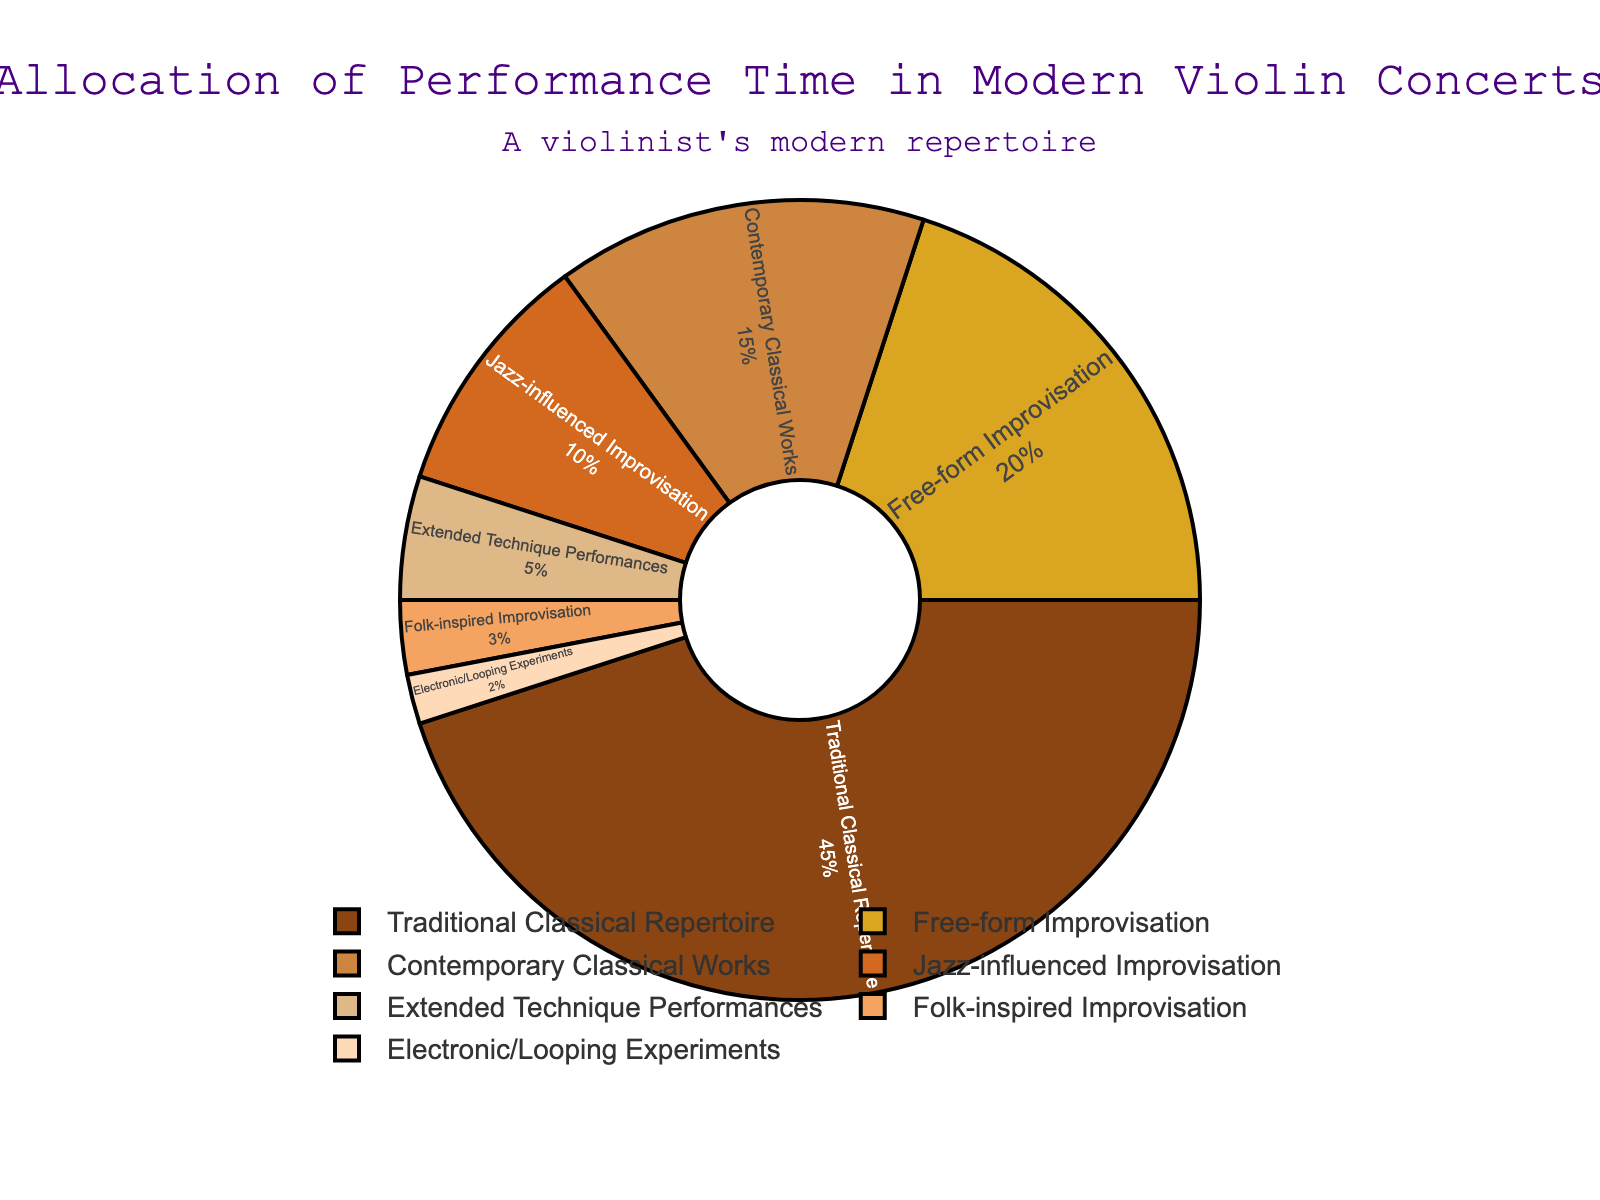What percentage of the performance time is allocated to improvisation (free-form, jazz-influenced, and folk-inspired combined)? Add percentages for Free-form Improvisation (20%), Jazz-influenced Improvisation (10%), and Folk-inspired Improvisation (3%): 20 + 10 + 3 = 33
Answer: 33 Which category has the largest share of performance time? The pie chart shows that Traditional Classical Repertoire has the largest segment, accounting for 45% of the performance time
Answer: Traditional Classical Repertoire Is the performance time allocated to Electronic/Looping Experiments greater than that for Folk-inspired Improvisation? Compare percentages: Electronic/Looping Experiments (2%) and Folk-inspired Improvisation (3%). 2% is less than 3%
Answer: No How does the percentage of Contemporary Classical Works compare to Jazz-influenced Improvisation? Contemporary Classical Works is 15%, while Jazz-influenced Improvisation is 10%. Since 15% > 10%, Contemporary Classical Works has a higher percentage
Answer: Contemporary Classical Works has a higher percentage What is the difference between the performance time allocated to the largest and smallest categories? The largest category is Traditional Classical Repertoire (45%) and the smallest is Electronic/Looping Experiments (2%). Calculate the difference: 45 - 2 = 43
Answer: 43 